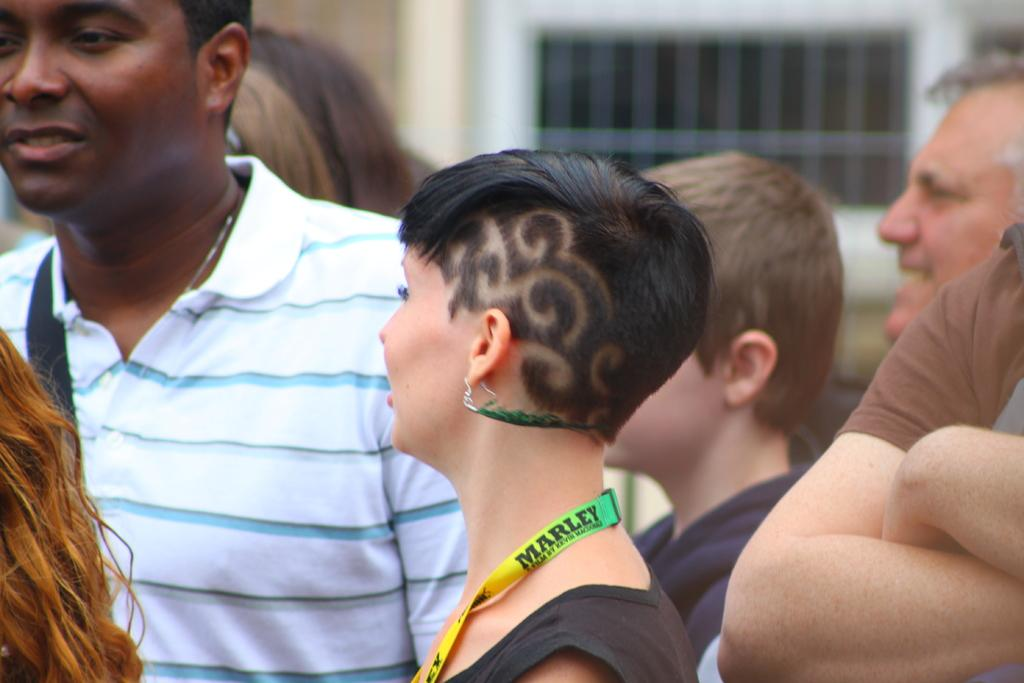Who or what is present in the image? There are people in the image. Can you describe the background of the image? The background of the image is blurred. What type of dinosaurs can be seen in the image? There are no dinosaurs present in the image; it features people. Is there a guide present in the image to provide information about the people? There is no guide present in the image; it simply shows people without any additional context or information. 